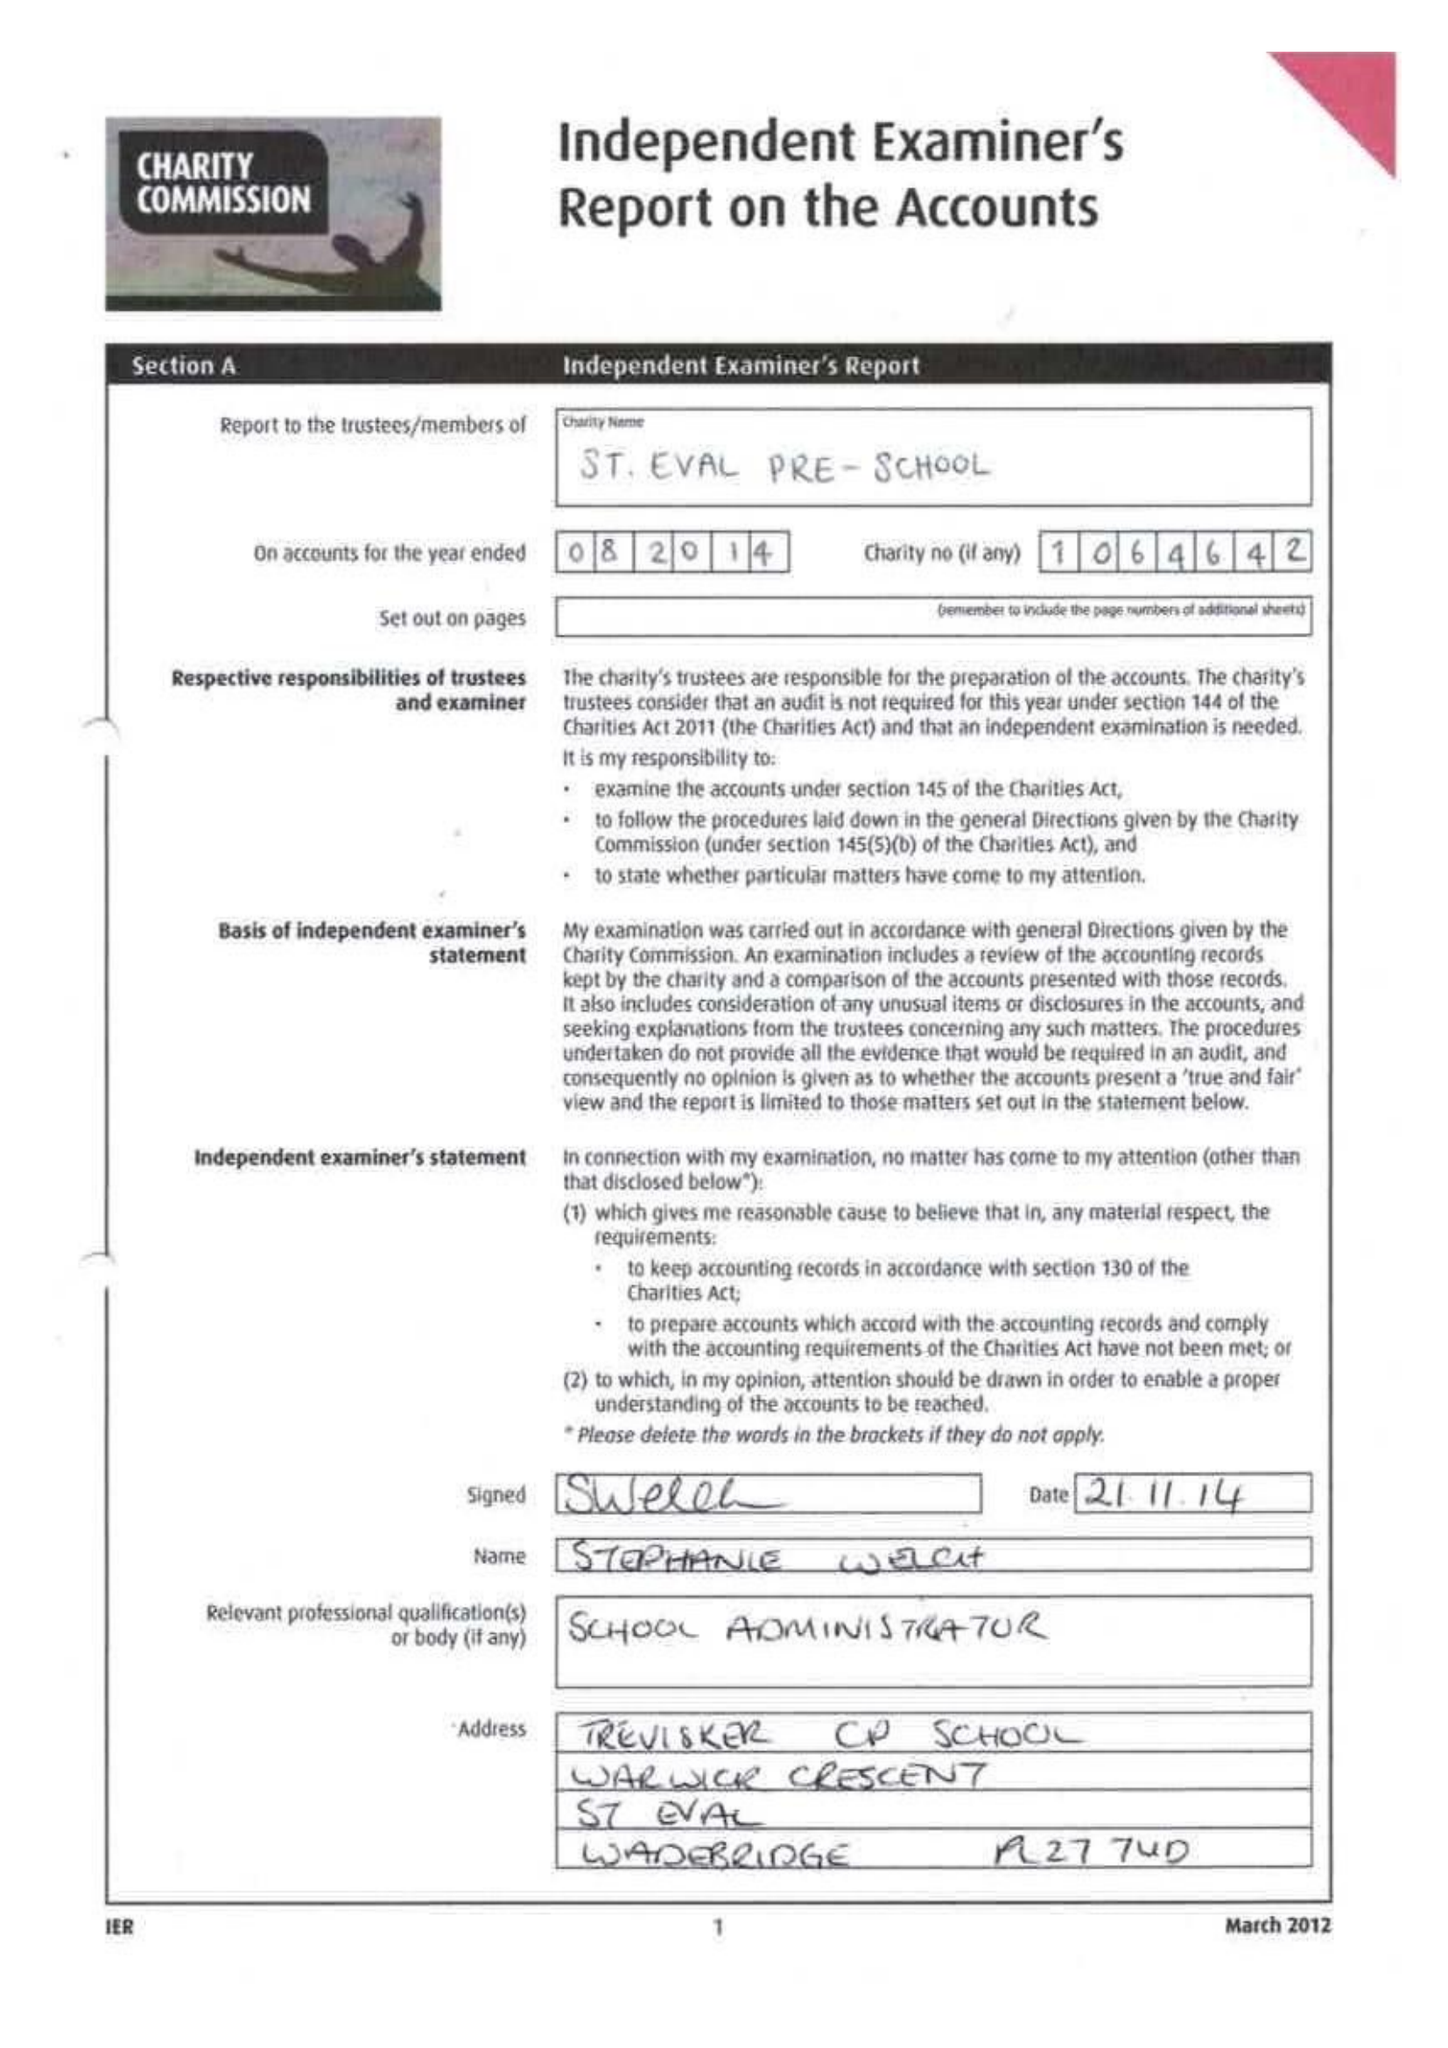What is the value for the address__post_town?
Answer the question using a single word or phrase. WADEBRIDGE 